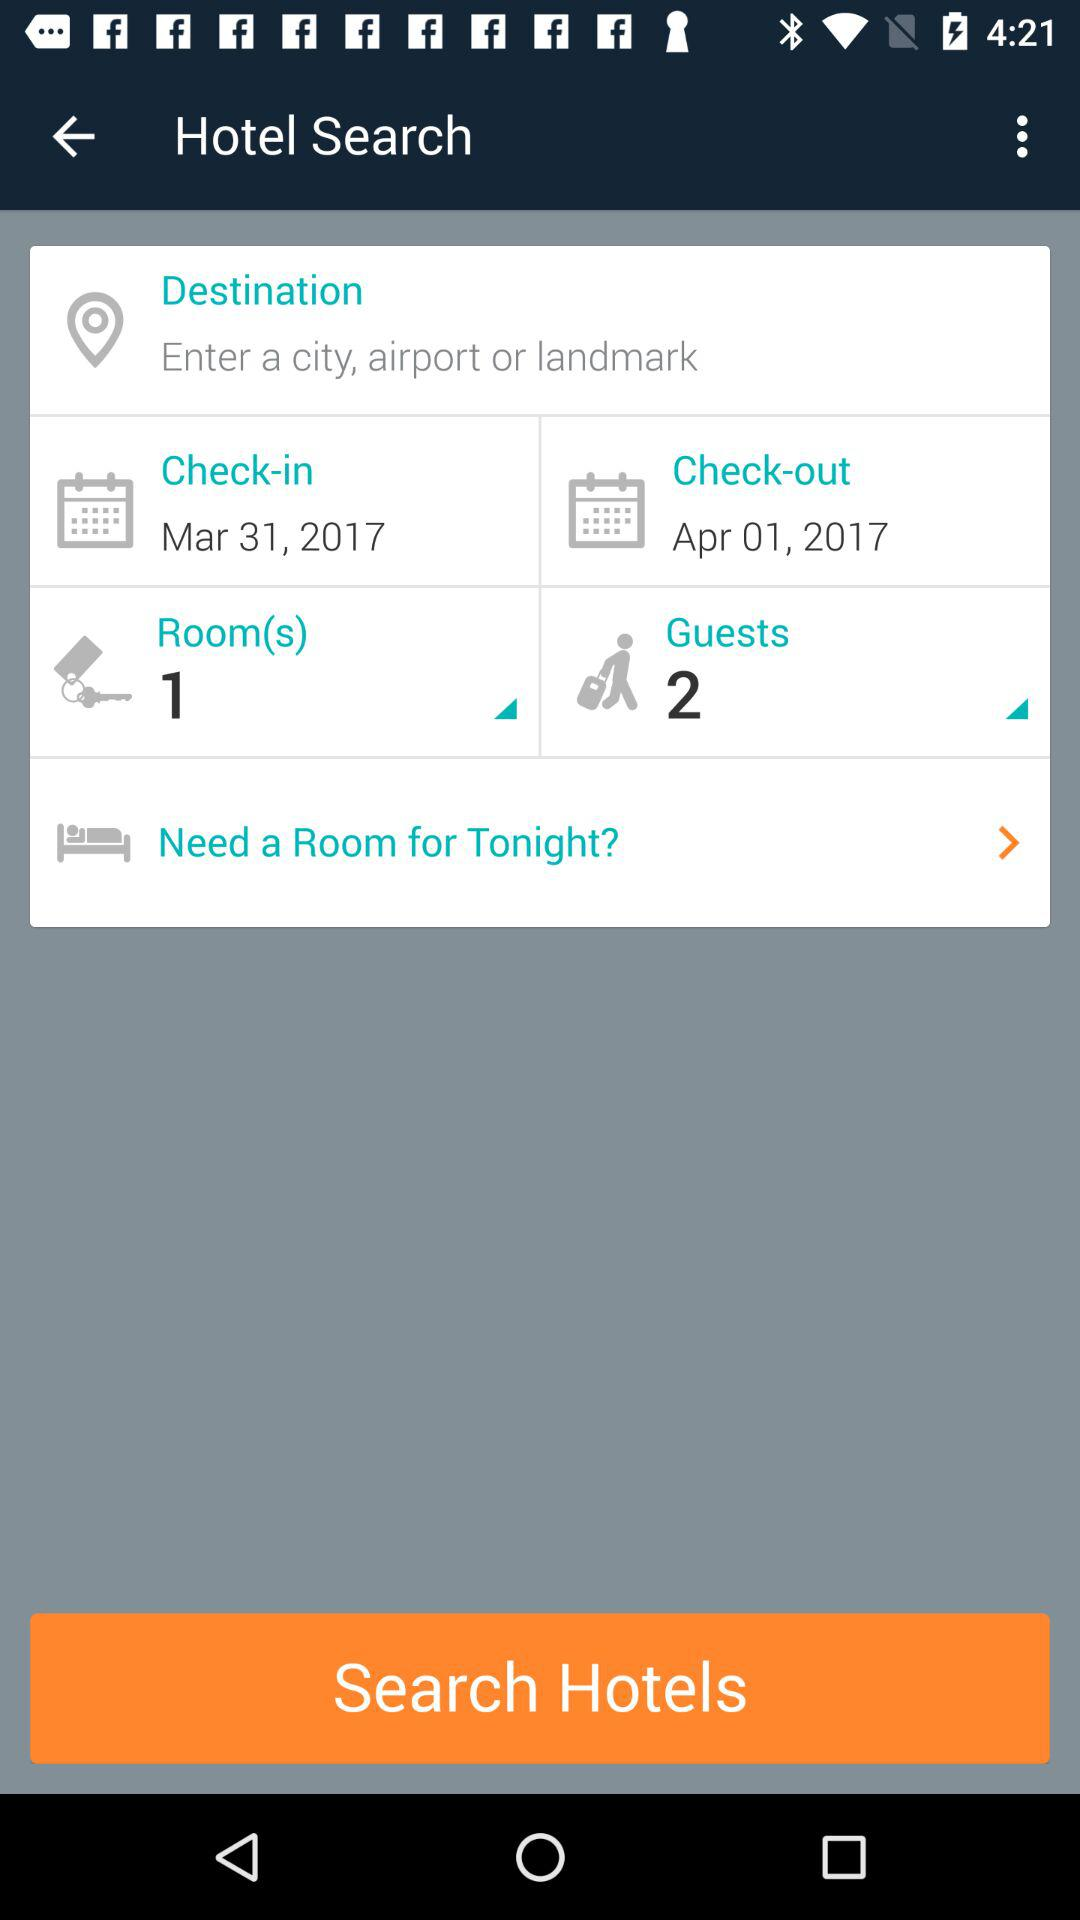How many days are between the check-in and check-out dates?
Answer the question using a single word or phrase. 1 